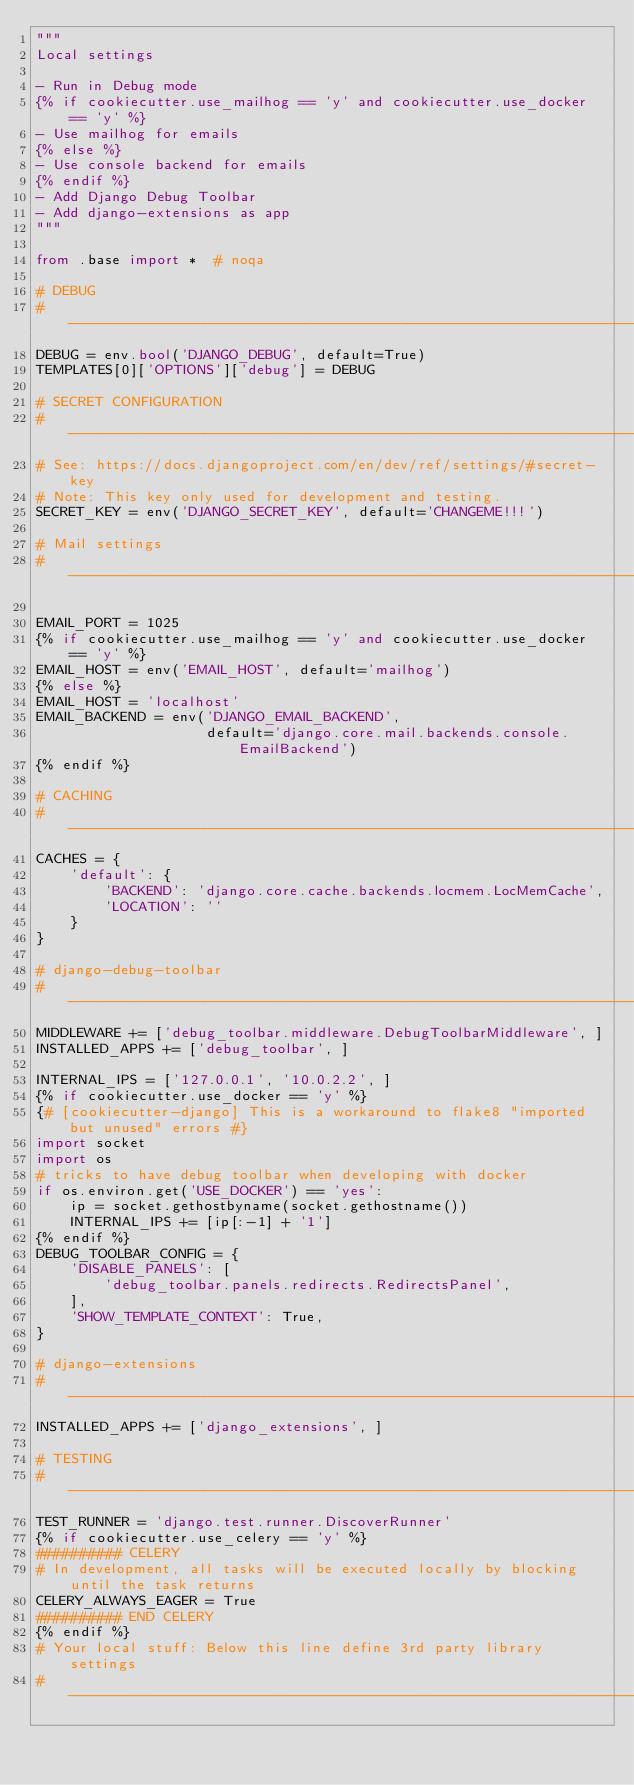<code> <loc_0><loc_0><loc_500><loc_500><_Python_>"""
Local settings

- Run in Debug mode
{% if cookiecutter.use_mailhog == 'y' and cookiecutter.use_docker == 'y' %}
- Use mailhog for emails
{% else %}
- Use console backend for emails
{% endif %}
- Add Django Debug Toolbar
- Add django-extensions as app
"""

from .base import *  # noqa

# DEBUG
# ------------------------------------------------------------------------------
DEBUG = env.bool('DJANGO_DEBUG', default=True)
TEMPLATES[0]['OPTIONS']['debug'] = DEBUG

# SECRET CONFIGURATION
# ------------------------------------------------------------------------------
# See: https://docs.djangoproject.com/en/dev/ref/settings/#secret-key
# Note: This key only used for development and testing.
SECRET_KEY = env('DJANGO_SECRET_KEY', default='CHANGEME!!!')

# Mail settings
# ------------------------------------------------------------------------------

EMAIL_PORT = 1025
{% if cookiecutter.use_mailhog == 'y' and cookiecutter.use_docker == 'y' %}
EMAIL_HOST = env('EMAIL_HOST', default='mailhog')
{% else %}
EMAIL_HOST = 'localhost'
EMAIL_BACKEND = env('DJANGO_EMAIL_BACKEND',
                    default='django.core.mail.backends.console.EmailBackend')
{% endif %}

# CACHING
# ------------------------------------------------------------------------------
CACHES = {
    'default': {
        'BACKEND': 'django.core.cache.backends.locmem.LocMemCache',
        'LOCATION': ''
    }
}

# django-debug-toolbar
# ------------------------------------------------------------------------------
MIDDLEWARE += ['debug_toolbar.middleware.DebugToolbarMiddleware', ]
INSTALLED_APPS += ['debug_toolbar', ]

INTERNAL_IPS = ['127.0.0.1', '10.0.2.2', ]
{% if cookiecutter.use_docker == 'y' %}
{# [cookiecutter-django] This is a workaround to flake8 "imported but unused" errors #}
import socket
import os
# tricks to have debug toolbar when developing with docker
if os.environ.get('USE_DOCKER') == 'yes':
    ip = socket.gethostbyname(socket.gethostname())
    INTERNAL_IPS += [ip[:-1] + '1']
{% endif %}
DEBUG_TOOLBAR_CONFIG = {
    'DISABLE_PANELS': [
        'debug_toolbar.panels.redirects.RedirectsPanel',
    ],
    'SHOW_TEMPLATE_CONTEXT': True,
}

# django-extensions
# ------------------------------------------------------------------------------
INSTALLED_APPS += ['django_extensions', ]

# TESTING
# ------------------------------------------------------------------------------
TEST_RUNNER = 'django.test.runner.DiscoverRunner'
{% if cookiecutter.use_celery == 'y' %}
########## CELERY
# In development, all tasks will be executed locally by blocking until the task returns
CELERY_ALWAYS_EAGER = True
########## END CELERY
{% endif %}
# Your local stuff: Below this line define 3rd party library settings
# ------------------------------------------------------------------------------
</code> 